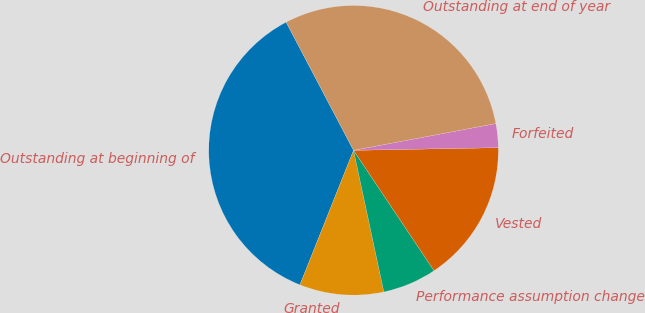<chart> <loc_0><loc_0><loc_500><loc_500><pie_chart><fcel>Outstanding at beginning of<fcel>Granted<fcel>Performance assumption change<fcel>Vested<fcel>Forfeited<fcel>Outstanding at end of year<nl><fcel>36.26%<fcel>9.39%<fcel>6.03%<fcel>15.91%<fcel>2.67%<fcel>29.75%<nl></chart> 